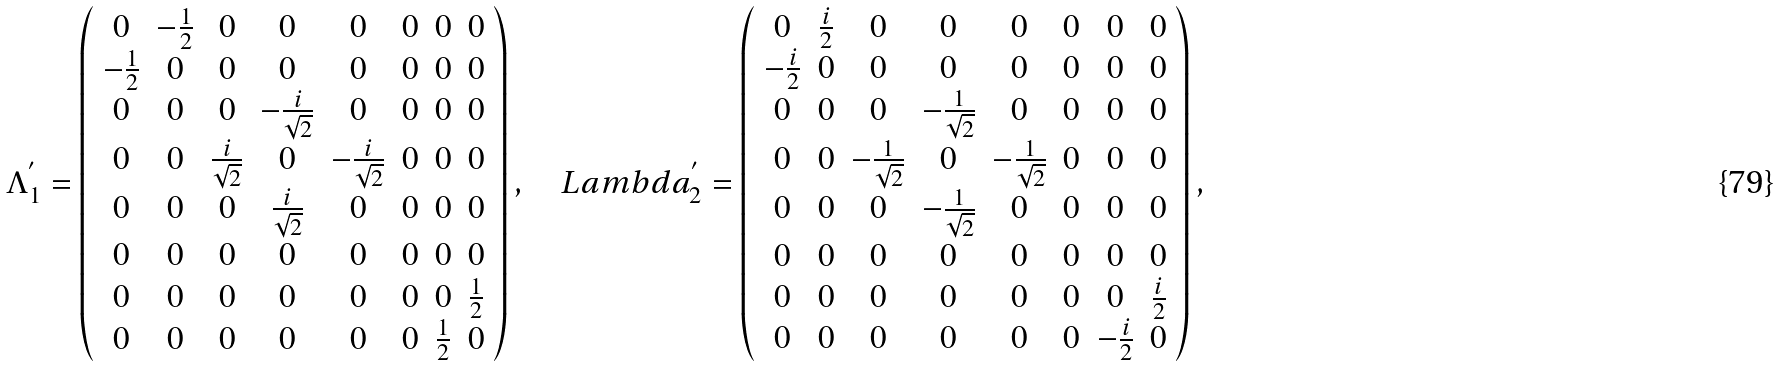<formula> <loc_0><loc_0><loc_500><loc_500>\Lambda ^ { ^ { \prime } } _ { 1 } = \left ( \begin{array} { c c c c c c c c } 0 & - \frac { 1 } { 2 } & 0 & 0 & 0 & 0 & 0 & 0 \\ - \frac { 1 } { 2 } & 0 & 0 & 0 & 0 & 0 & 0 & 0 \\ 0 & 0 & 0 & - \frac { i } { \sqrt { 2 } } & 0 & 0 & 0 & 0 \\ 0 & 0 & \frac { i } { \sqrt { 2 } } & 0 & - \frac { i } { \sqrt { 2 } } & 0 & 0 & 0 \\ 0 & 0 & 0 & \frac { i } { \sqrt { 2 } } & 0 & 0 & 0 & 0 \\ 0 & 0 & 0 & 0 & 0 & 0 & 0 & 0 \\ 0 & 0 & 0 & 0 & 0 & 0 & 0 & \frac { 1 } { 2 } \\ 0 & 0 & 0 & 0 & 0 & 0 & \frac { 1 } { 2 } & 0 \\ \end{array} \right ) , \quad L a m b d a ^ { ^ { \prime } } _ { 2 } = \left ( \begin{array} { c c c c c c c c } 0 & \frac { i } { 2 } & 0 & 0 & 0 & 0 & 0 & 0 \\ - \frac { i } { 2 } & 0 & 0 & 0 & 0 & 0 & 0 & 0 \\ 0 & 0 & 0 & - \frac { 1 } { \sqrt { 2 } } & 0 & 0 & 0 & 0 \\ 0 & 0 & - \frac { 1 } { \sqrt { 2 } } & 0 & - \frac { 1 } { \sqrt { 2 } } & 0 & 0 & 0 \\ 0 & 0 & 0 & - \frac { 1 } { \sqrt { 2 } } & 0 & 0 & 0 & 0 \\ 0 & 0 & 0 & 0 & 0 & 0 & 0 & 0 \\ 0 & 0 & 0 & 0 & 0 & 0 & 0 & \frac { i } { 2 } \\ 0 & 0 & 0 & 0 & 0 & 0 & - \frac { i } { 2 } & 0 \\ \end{array} \right ) ,</formula> 